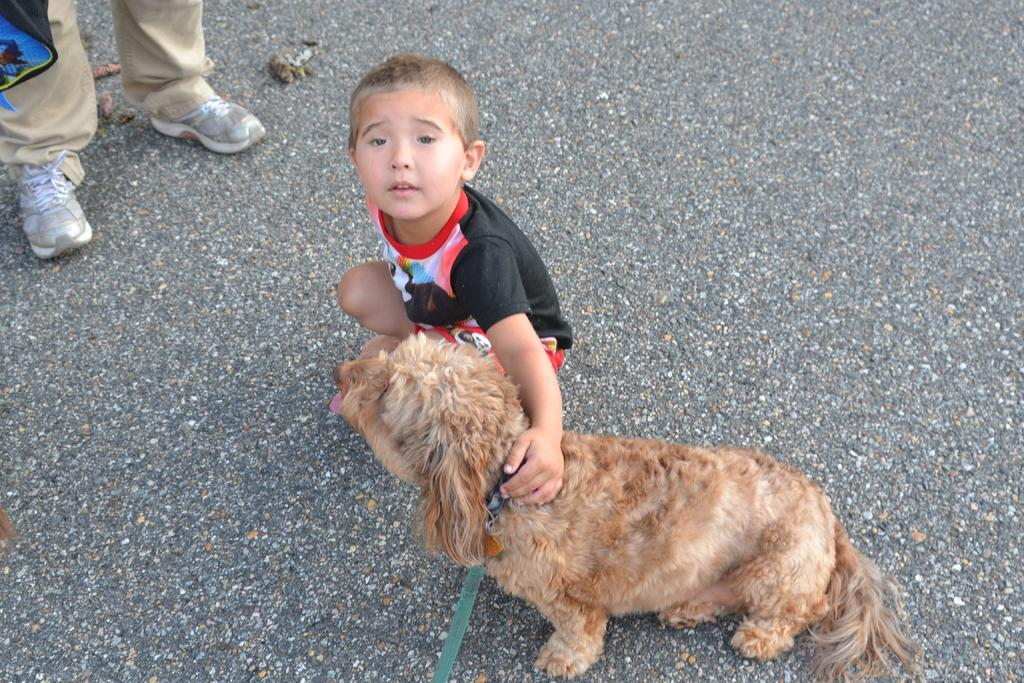What is the primary subject of the image? There is a man standing in the image. What is the child doing in the image? There is a child sitting in the image. Who or what is the child sitting with? The child is sitting with a dog. Where are the man, child, and dog located in the image? The man, child, and dog are on the road. What type of bulb is being used to light up the scarecrow in the image? There is no bulb or scarecrow present in the image. What property is visible in the background of the image? There is no property visible in the image; it only features the man, child, dog, and the road. 